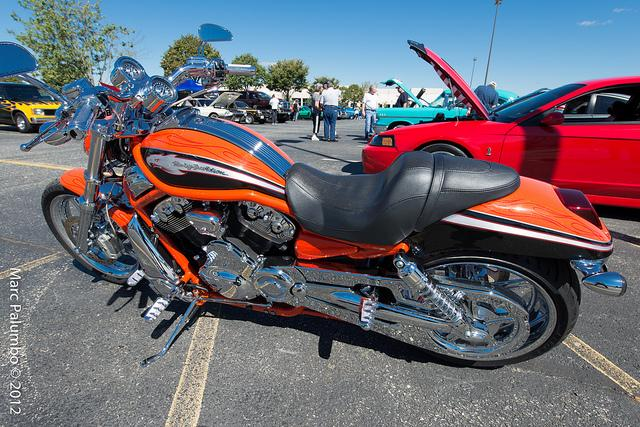What is the silver area of the bike made of? chrome 